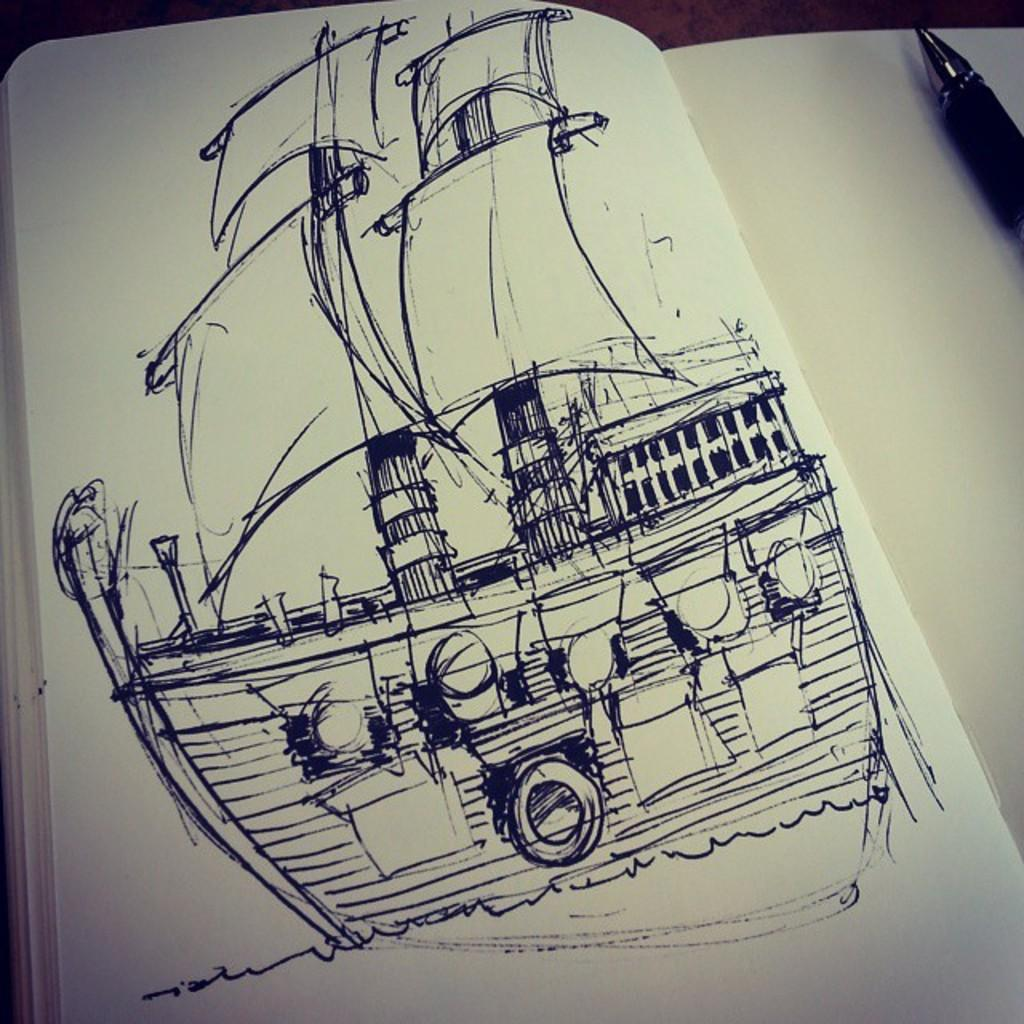What is depicted on the paper in the image? There is a drawing of a ship on the paper. Can you describe any writing instruments visible in the image? Yes, there is a pen in the top right corner of the image. How many light bulbs are present in the image? There are no light bulbs visible in the image. What type of stove is shown in the image? There is no stove present in the image. 